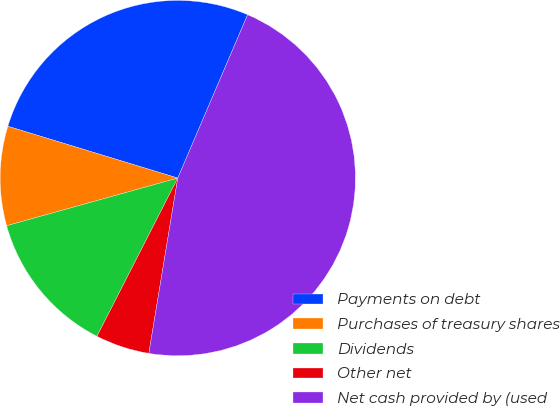<chart> <loc_0><loc_0><loc_500><loc_500><pie_chart><fcel>Payments on debt<fcel>Purchases of treasury shares<fcel>Dividends<fcel>Other net<fcel>Net cash provided by (used<nl><fcel>26.72%<fcel>9.03%<fcel>13.16%<fcel>4.91%<fcel>46.17%<nl></chart> 